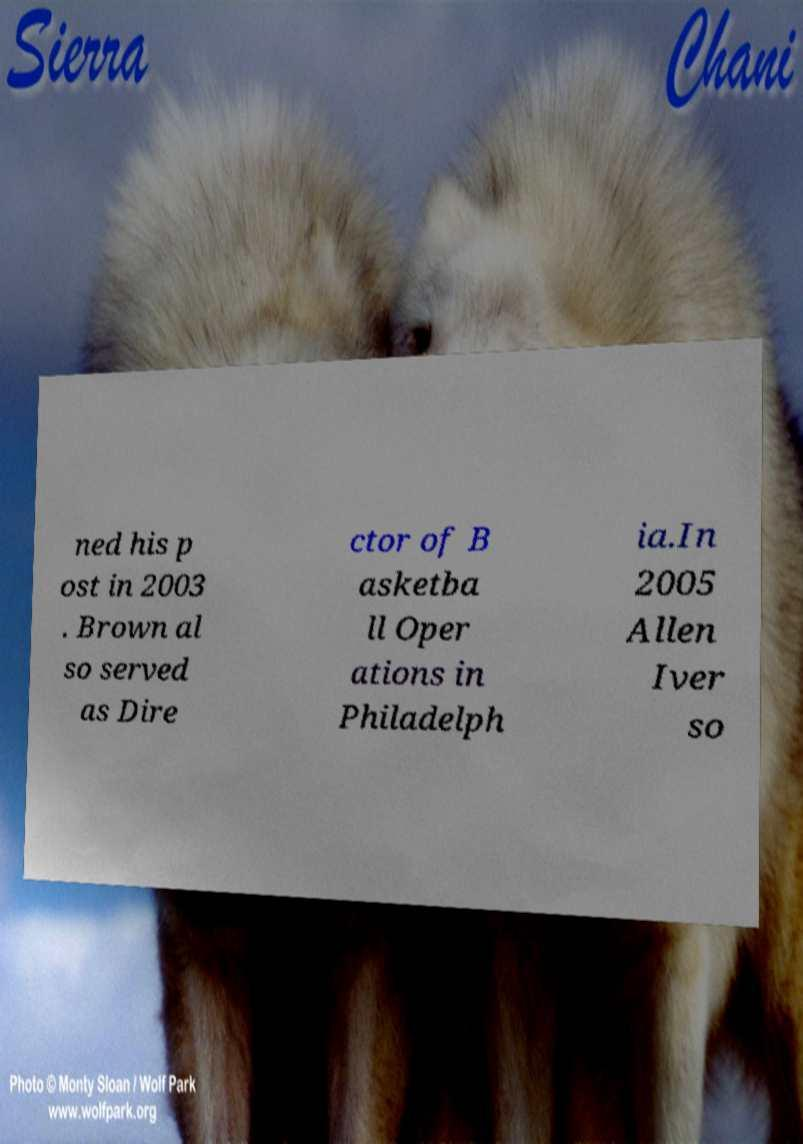I need the written content from this picture converted into text. Can you do that? ned his p ost in 2003 . Brown al so served as Dire ctor of B asketba ll Oper ations in Philadelph ia.In 2005 Allen Iver so 